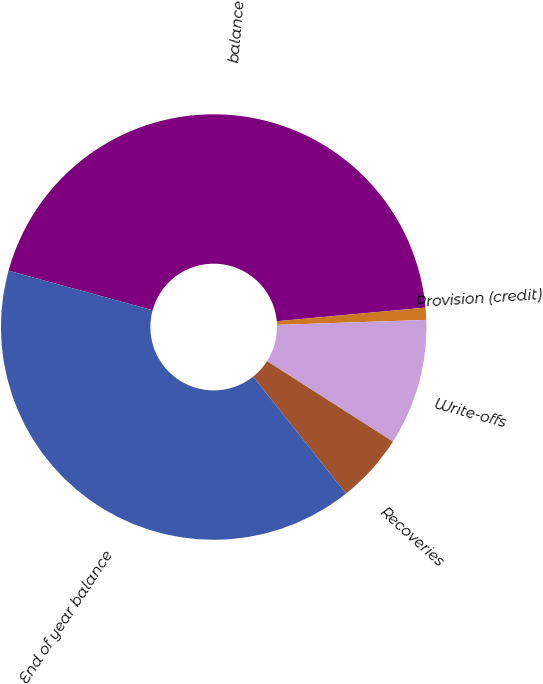Convert chart. <chart><loc_0><loc_0><loc_500><loc_500><pie_chart><fcel>balance<fcel>Provision (credit)<fcel>Write-offs<fcel>Recoveries<fcel>End of year balance<nl><fcel>44.28%<fcel>0.92%<fcel>9.59%<fcel>5.26%<fcel>39.95%<nl></chart> 